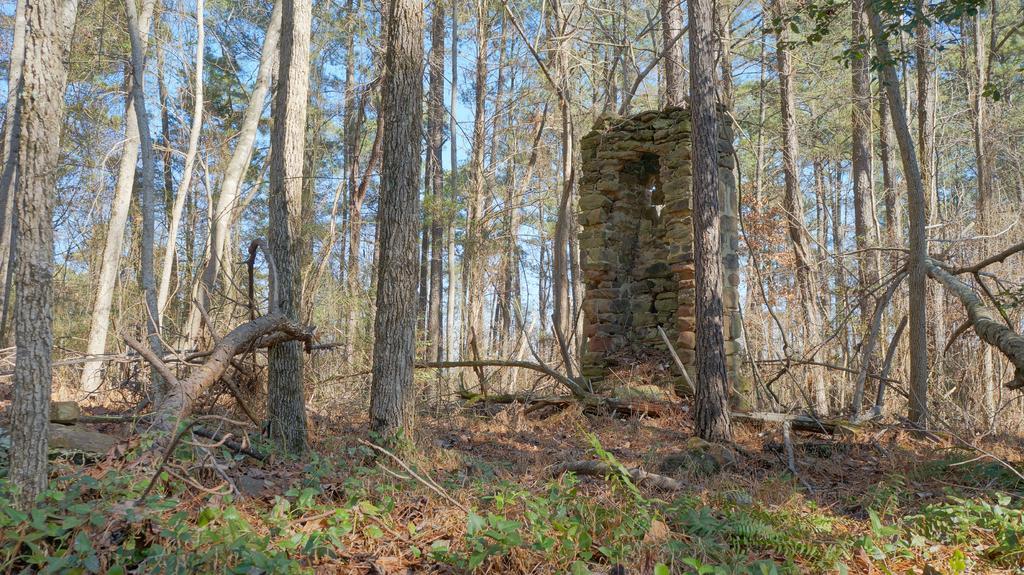Can you describe this image briefly? In the center of the image we can see a stone wall, a group of trees and the sky. At the bottom of the image we can see some plants. 